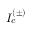Convert formula to latex. <formula><loc_0><loc_0><loc_500><loc_500>I _ { c } ^ { ( \pm ) }</formula> 